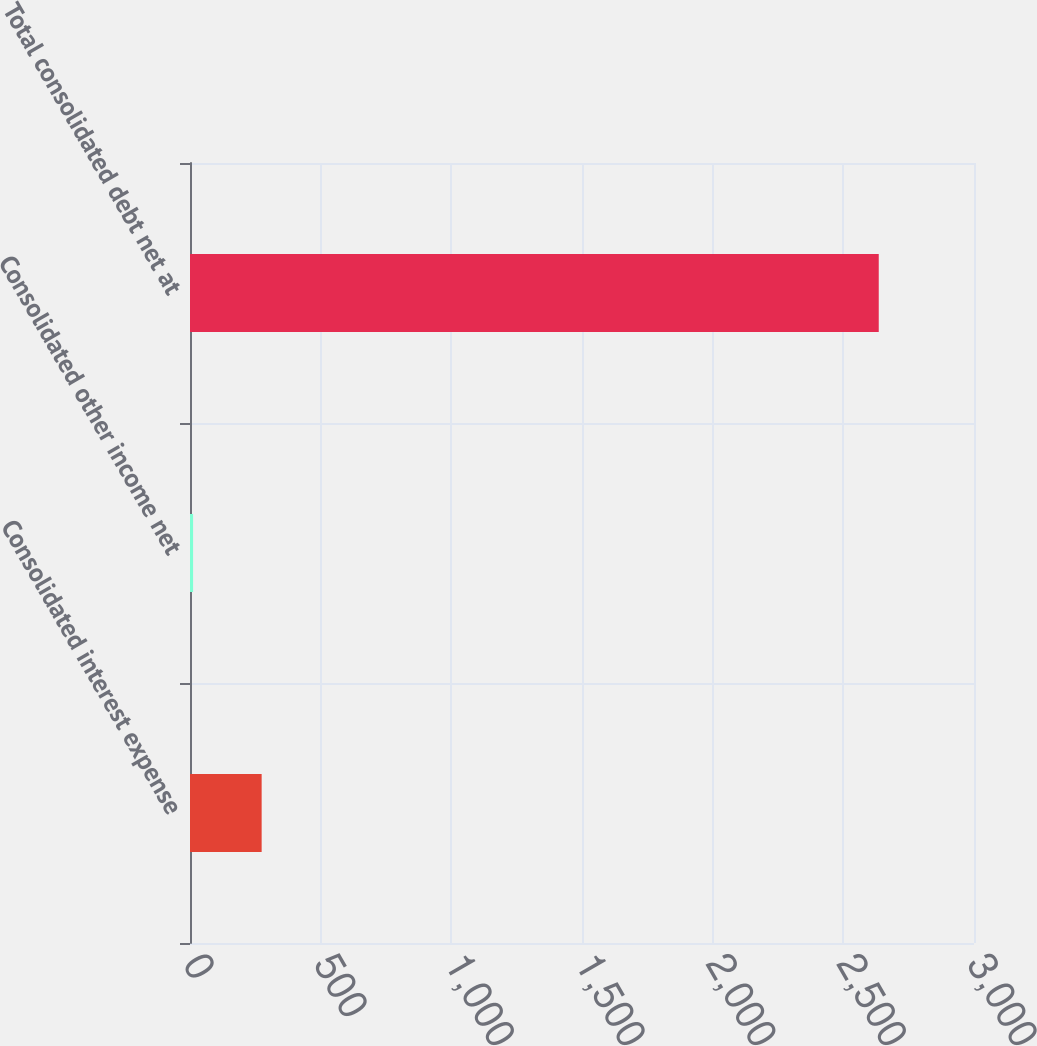<chart> <loc_0><loc_0><loc_500><loc_500><bar_chart><fcel>Consolidated interest expense<fcel>Consolidated other income net<fcel>Total consolidated debt net at<nl><fcel>274.17<fcel>11.8<fcel>2635.5<nl></chart> 